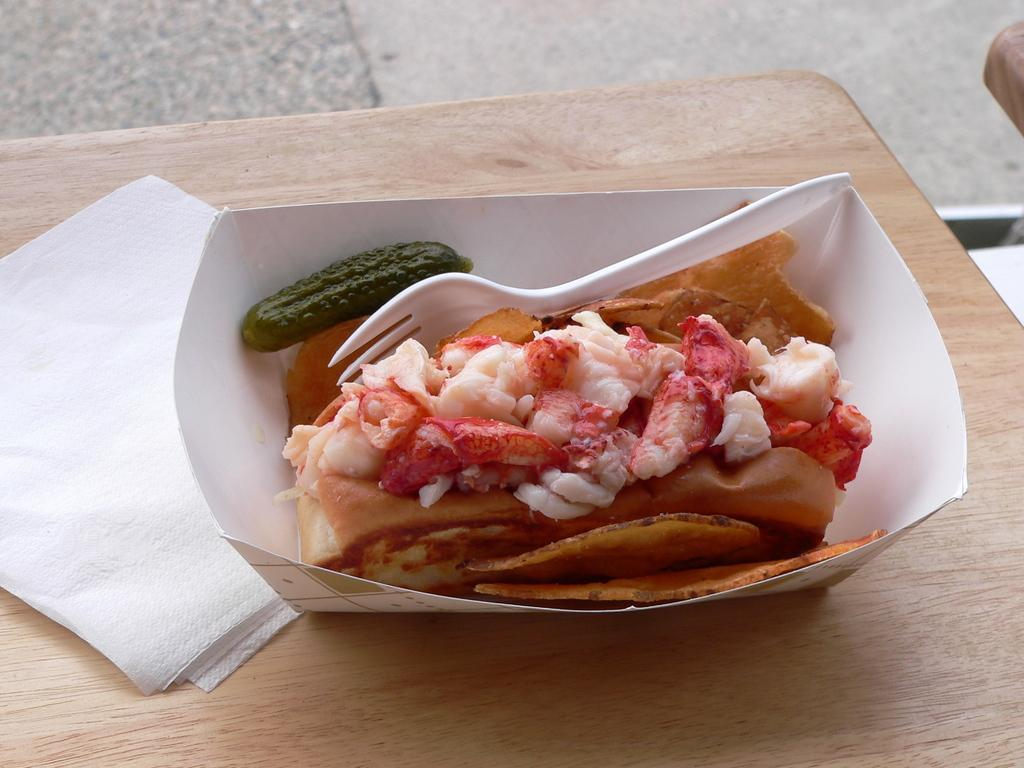What type of container is holding the food in the image? There is a box holding the food in the image. What utensil is included with the food in the box? There is a plastic spoon inside the box. On what surface is the box and food placed? The food and box are placed on a wooden table. Can you tell me how many fish are swimming in the tank in the image? There is no fish tank or swimming fish present in the image. 